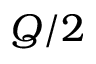Convert formula to latex. <formula><loc_0><loc_0><loc_500><loc_500>Q / 2</formula> 